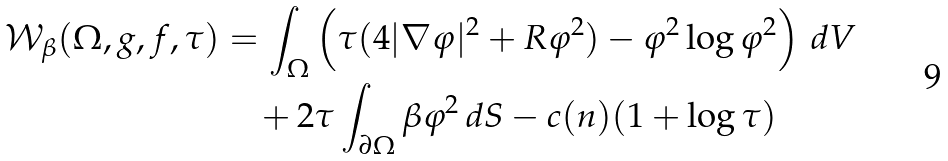<formula> <loc_0><loc_0><loc_500><loc_500>\mathcal { W } _ { \beta } ( \Omega , g , f , \tau ) & = \int _ { \Omega } \left ( \tau ( 4 | \nabla \varphi | ^ { 2 } + R \varphi ^ { 2 } ) - \varphi ^ { 2 } \log \varphi ^ { 2 } \right ) \, d V \\ & \quad + 2 \tau \int _ { \partial \Omega } \beta \varphi ^ { 2 } \, d S - c ( n ) ( 1 + \log \tau )</formula> 